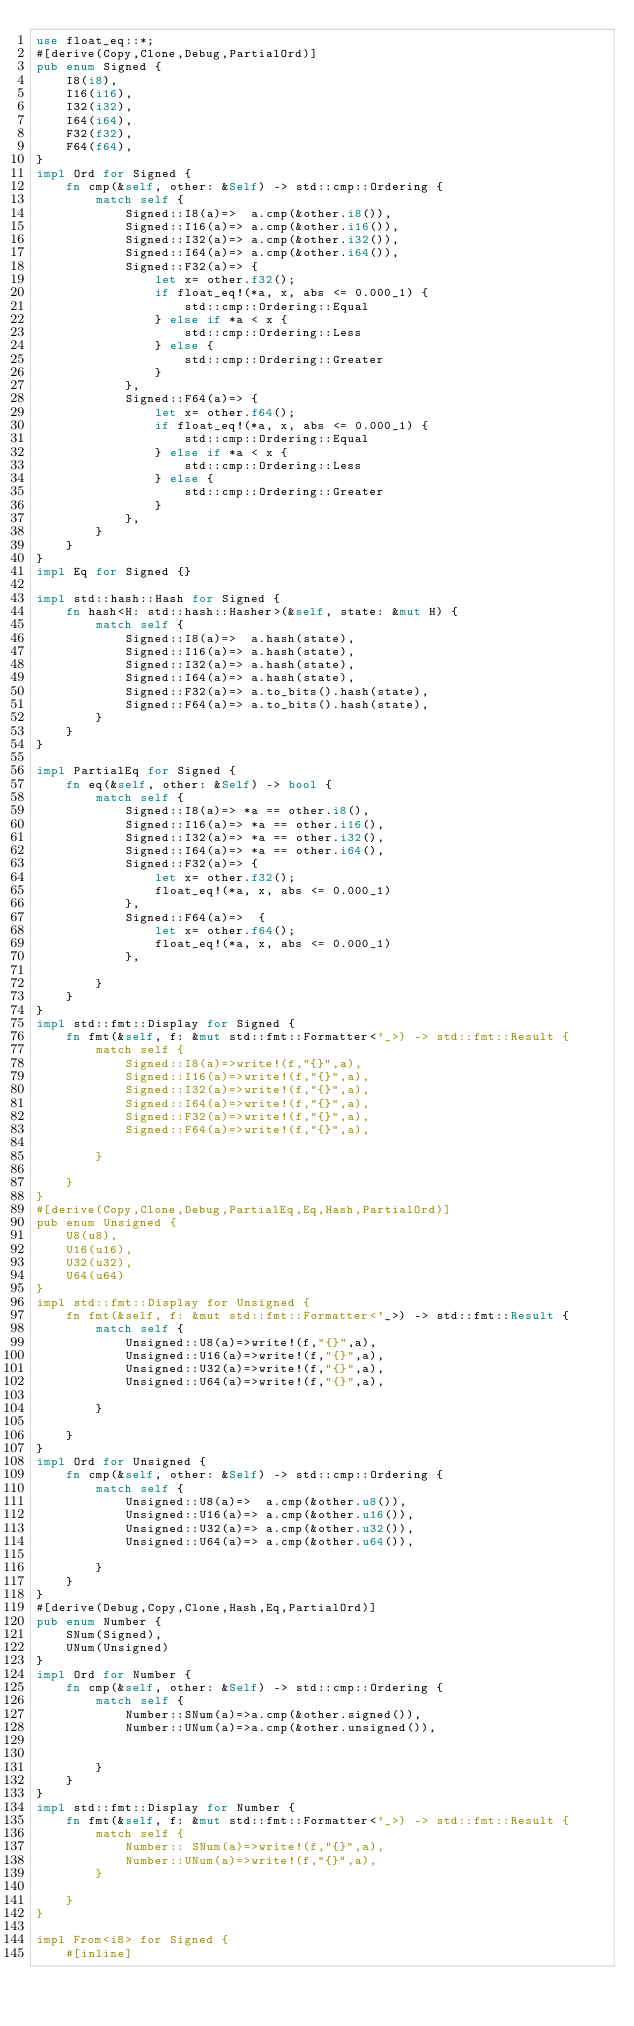Convert code to text. <code><loc_0><loc_0><loc_500><loc_500><_Rust_>use float_eq::*;
#[derive(Copy,Clone,Debug,PartialOrd)]
pub enum Signed {
    I8(i8),
    I16(i16),
    I32(i32),
    I64(i64),
    F32(f32),
    F64(f64),
} 
impl Ord for Signed {
    fn cmp(&self, other: &Self) -> std::cmp::Ordering {
        match self {
            Signed::I8(a)=>  a.cmp(&other.i8()),
            Signed::I16(a)=> a.cmp(&other.i16()),
            Signed::I32(a)=> a.cmp(&other.i32()),
            Signed::I64(a)=> a.cmp(&other.i64()),
            Signed::F32(a)=> {
                let x= other.f32();
                if float_eq!(*a, x, abs <= 0.000_1) {
                    std::cmp::Ordering::Equal
                } else if *a < x {
                    std::cmp::Ordering::Less
                } else {
                    std::cmp::Ordering::Greater
                }
            },
            Signed::F64(a)=> {
                let x= other.f64();
                if float_eq!(*a, x, abs <= 0.000_1) {
                    std::cmp::Ordering::Equal
                } else if *a < x {
                    std::cmp::Ordering::Less
                } else {
                    std::cmp::Ordering::Greater
                }
            },
        }
    }
}
impl Eq for Signed {}

impl std::hash::Hash for Signed {
    fn hash<H: std::hash::Hasher>(&self, state: &mut H) {
        match self {
            Signed::I8(a)=>  a.hash(state),
            Signed::I16(a)=> a.hash(state),
            Signed::I32(a)=> a.hash(state),
            Signed::I64(a)=> a.hash(state),
            Signed::F32(a)=> a.to_bits().hash(state),
            Signed::F64(a)=> a.to_bits().hash(state),
        }
    }
}

impl PartialEq for Signed {
    fn eq(&self, other: &Self) -> bool {
        match self {
            Signed::I8(a)=> *a == other.i8(),
            Signed::I16(a)=> *a == other.i16(),
            Signed::I32(a)=> *a == other.i32(),
            Signed::I64(a)=> *a == other.i64(),
            Signed::F32(a)=> {
                let x= other.f32();
                float_eq!(*a, x, abs <= 0.000_1)
            },
            Signed::F64(a)=>  {
                let x= other.f64();
                float_eq!(*a, x, abs <= 0.000_1)
            },
            
        }
    }
}
impl std::fmt::Display for Signed {
    fn fmt(&self, f: &mut std::fmt::Formatter<'_>) -> std::fmt::Result {
        match self {
            Signed::I8(a)=>write!(f,"{}",a),
            Signed::I16(a)=>write!(f,"{}",a),
            Signed::I32(a)=>write!(f,"{}",a),
            Signed::I64(a)=>write!(f,"{}",a),
            Signed::F32(a)=>write!(f,"{}",a),
            Signed::F64(a)=>write!(f,"{}",a),
            
        }
        
    }
}
#[derive(Copy,Clone,Debug,PartialEq,Eq,Hash,PartialOrd)]
pub enum Unsigned {
    U8(u8),
    U16(u16),
    U32(u32),
    U64(u64)
}
impl std::fmt::Display for Unsigned {
    fn fmt(&self, f: &mut std::fmt::Formatter<'_>) -> std::fmt::Result {
        match self {
            Unsigned::U8(a)=>write!(f,"{}",a),
            Unsigned::U16(a)=>write!(f,"{}",a),
            Unsigned::U32(a)=>write!(f,"{}",a),
            Unsigned::U64(a)=>write!(f,"{}",a),
            
        }
        
    }
}
impl Ord for Unsigned {
    fn cmp(&self, other: &Self) -> std::cmp::Ordering {
        match self {
            Unsigned::U8(a)=>  a.cmp(&other.u8()),
            Unsigned::U16(a)=> a.cmp(&other.u16()),
            Unsigned::U32(a)=> a.cmp(&other.u32()),
            Unsigned::U64(a)=> a.cmp(&other.u64()),
            
        }
    }
}
#[derive(Debug,Copy,Clone,Hash,Eq,PartialOrd)]
pub enum Number {
    SNum(Signed),
    UNum(Unsigned)
}
impl Ord for Number {
    fn cmp(&self, other: &Self) -> std::cmp::Ordering {
        match self {
            Number::SNum(a)=>a.cmp(&other.signed()),
            Number::UNum(a)=>a.cmp(&other.unsigned()),
            
            
        }
    }
}
impl std::fmt::Display for Number {
    fn fmt(&self, f: &mut std::fmt::Formatter<'_>) -> std::fmt::Result {
        match self {
            Number:: SNum(a)=>write!(f,"{}",a),
            Number::UNum(a)=>write!(f,"{}",a),
        }
        
    }
}

impl From<i8> for Signed {
    #[inline]</code> 